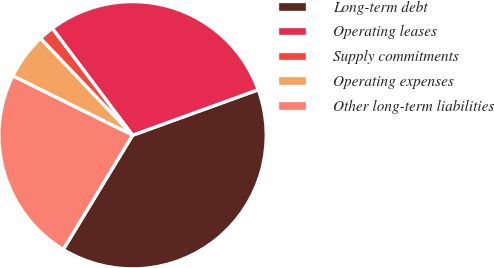Convert chart to OTSL. <chart><loc_0><loc_0><loc_500><loc_500><pie_chart><fcel>Long-term debt<fcel>Operating leases<fcel>Supply commitments<fcel>Operating expenses<fcel>Other long-term liabilities<nl><fcel>39.21%<fcel>29.73%<fcel>1.84%<fcel>5.58%<fcel>23.65%<nl></chart> 